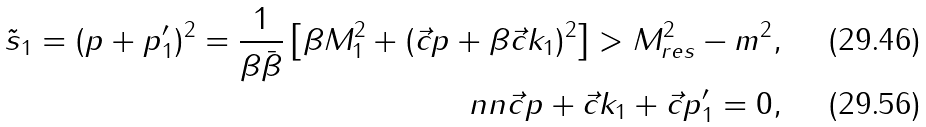<formula> <loc_0><loc_0><loc_500><loc_500>\tilde { s } _ { 1 } = ( p + p _ { 1 } ^ { \prime } ) ^ { 2 } = \frac { 1 } { \beta \bar { \beta } } \left [ \beta M _ { 1 } ^ { 2 } + ( \vec { c } { p } + \beta \vec { c } { k _ { 1 } } ) ^ { 2 } \right ] > M _ { r e s } ^ { 2 } - m ^ { 2 } , \\ \ n n \vec { c } { p } + \vec { c } { k _ { 1 } } + \vec { c } { p _ { 1 } ^ { \prime } } = 0 ,</formula> 